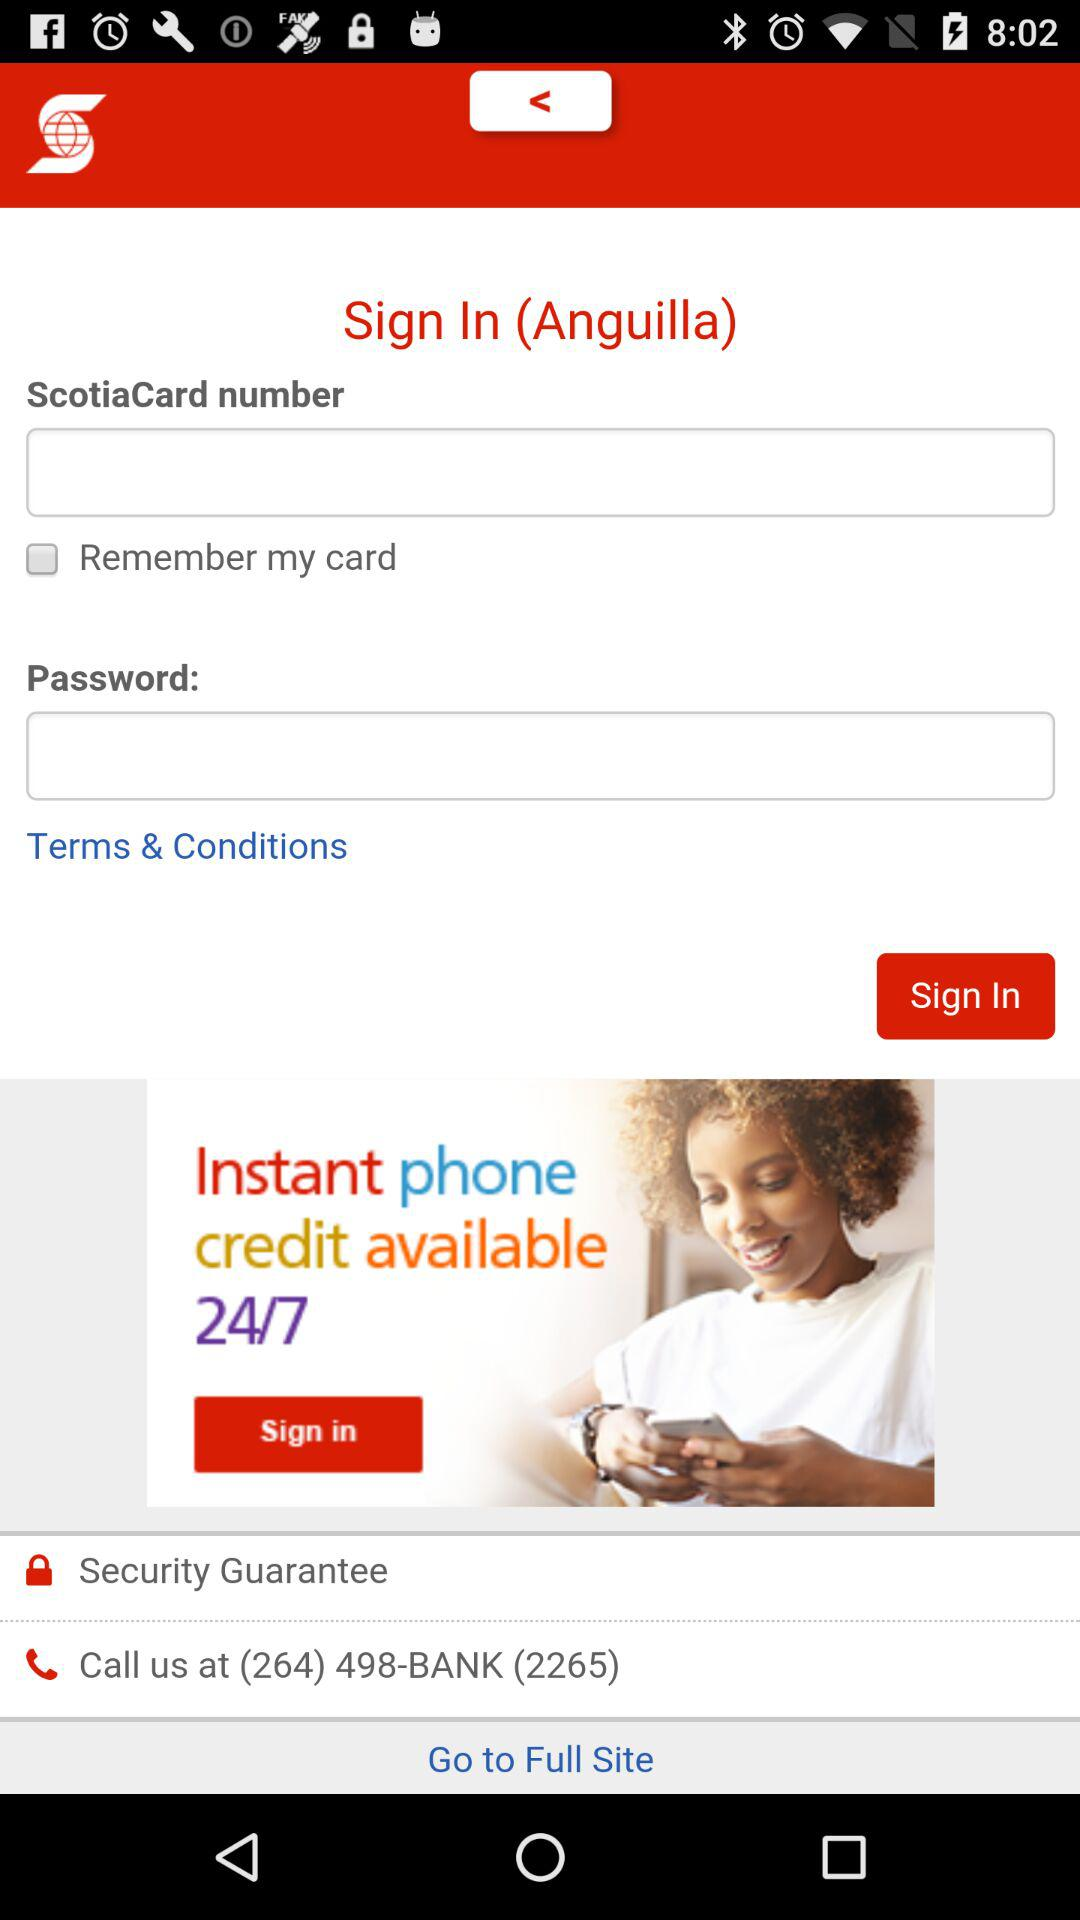How many more text inputs are there than checkboxes?
Answer the question using a single word or phrase. 1 